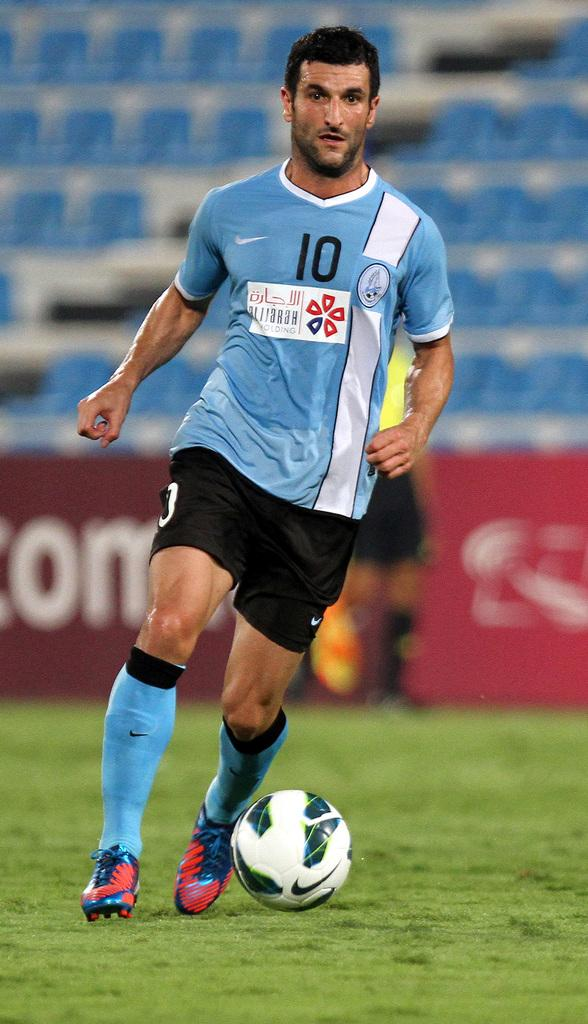<image>
Summarize the visual content of the image. a man wearing number 10 jersey kicking the soccer ball 